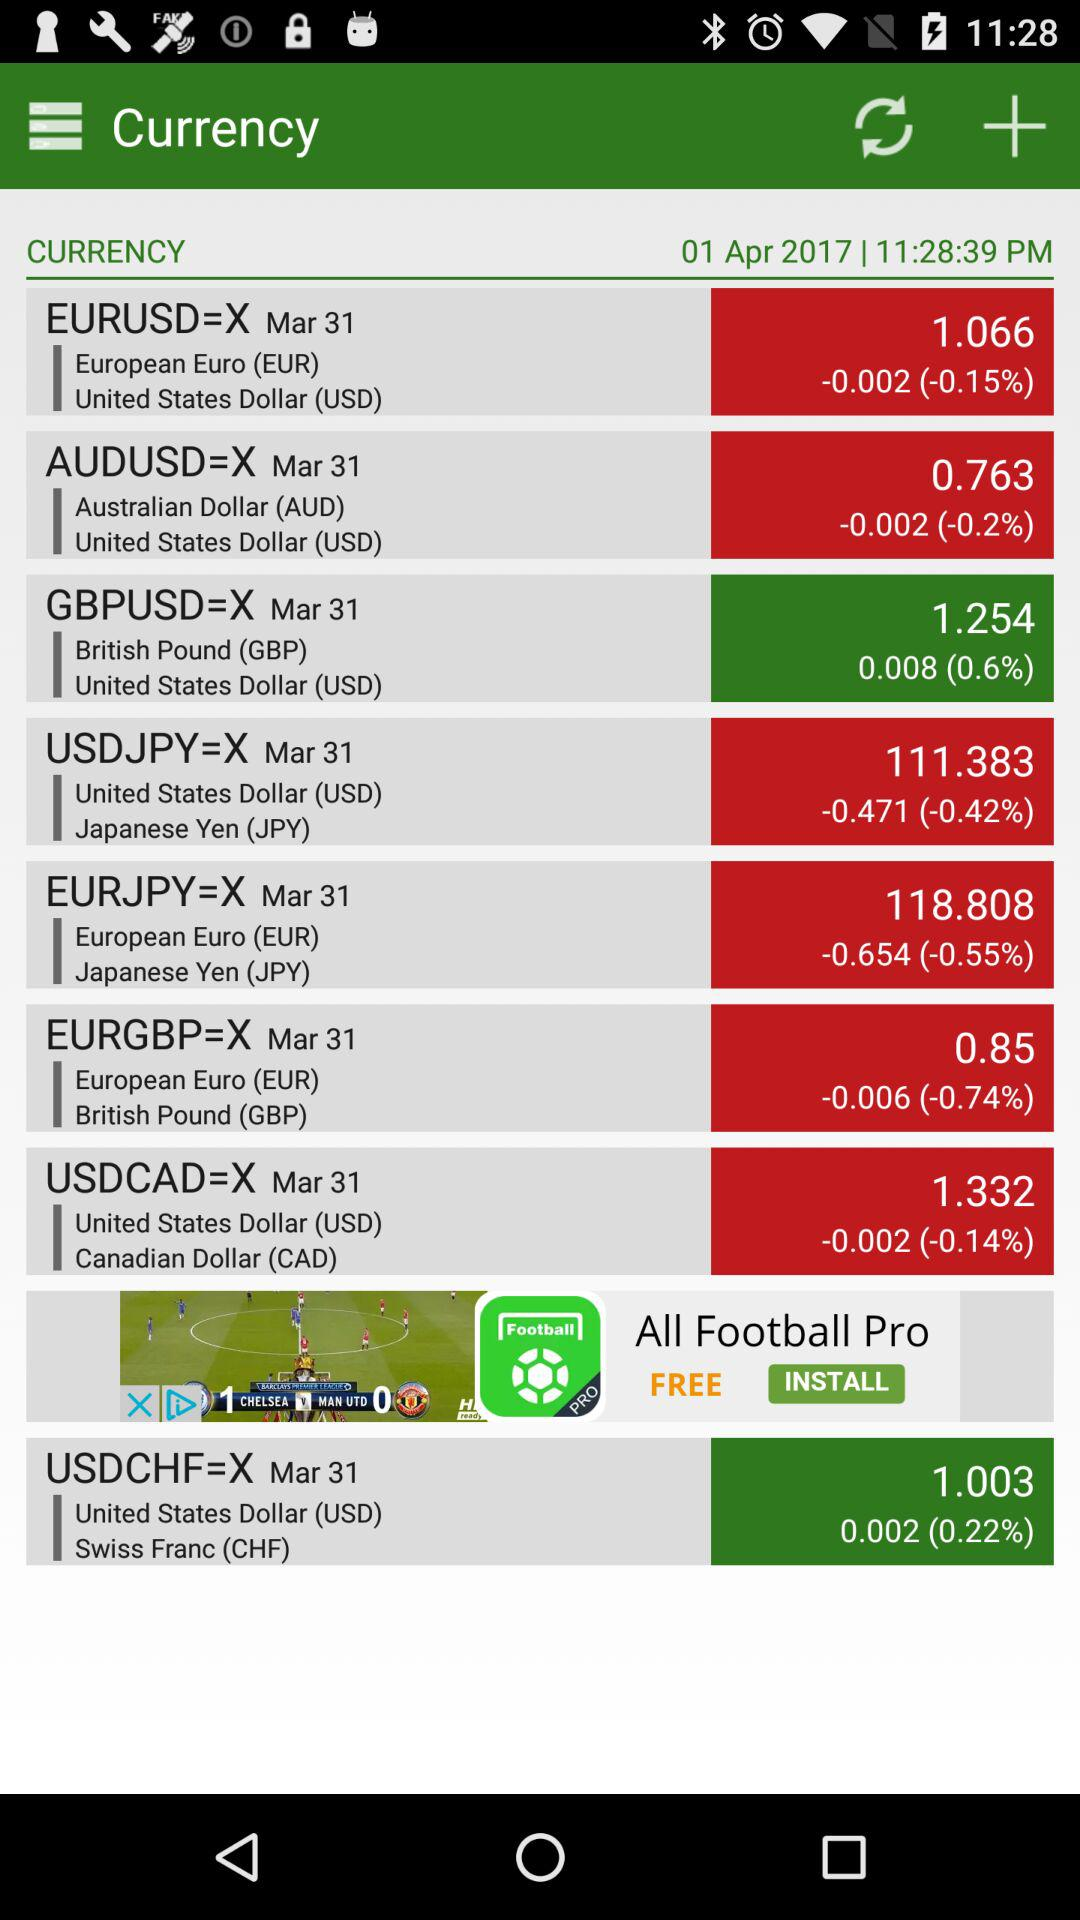What is the date? The date is April 01, 2017. 